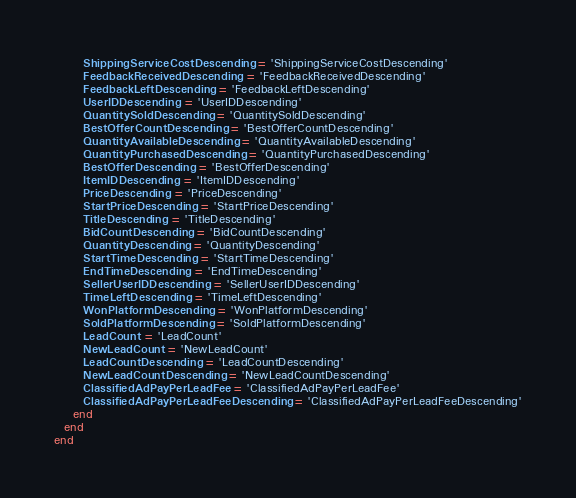<code> <loc_0><loc_0><loc_500><loc_500><_Ruby_>      ShippingServiceCostDescending = 'ShippingServiceCostDescending'
      FeedbackReceivedDescending = 'FeedbackReceivedDescending'
      FeedbackLeftDescending = 'FeedbackLeftDescending'
      UserIDDescending = 'UserIDDescending'
      QuantitySoldDescending = 'QuantitySoldDescending'
      BestOfferCountDescending = 'BestOfferCountDescending'
      QuantityAvailableDescending = 'QuantityAvailableDescending'
      QuantityPurchasedDescending = 'QuantityPurchasedDescending'
      BestOfferDescending = 'BestOfferDescending'
      ItemIDDescending = 'ItemIDDescending'
      PriceDescending = 'PriceDescending'
      StartPriceDescending = 'StartPriceDescending'
      TitleDescending = 'TitleDescending'
      BidCountDescending = 'BidCountDescending'
      QuantityDescending = 'QuantityDescending'
      StartTimeDescending = 'StartTimeDescending'
      EndTimeDescending = 'EndTimeDescending'
      SellerUserIDDescending = 'SellerUserIDDescending'
      TimeLeftDescending = 'TimeLeftDescending'
      WonPlatformDescending = 'WonPlatformDescending'
      SoldPlatformDescending = 'SoldPlatformDescending'
      LeadCount = 'LeadCount'
      NewLeadCount = 'NewLeadCount'
      LeadCountDescending = 'LeadCountDescending'
      NewLeadCountDescending = 'NewLeadCountDescending'
      ClassifiedAdPayPerLeadFee = 'ClassifiedAdPayPerLeadFee'
      ClassifiedAdPayPerLeadFeeDescending = 'ClassifiedAdPayPerLeadFeeDescending'
    end
  end
end

</code> 